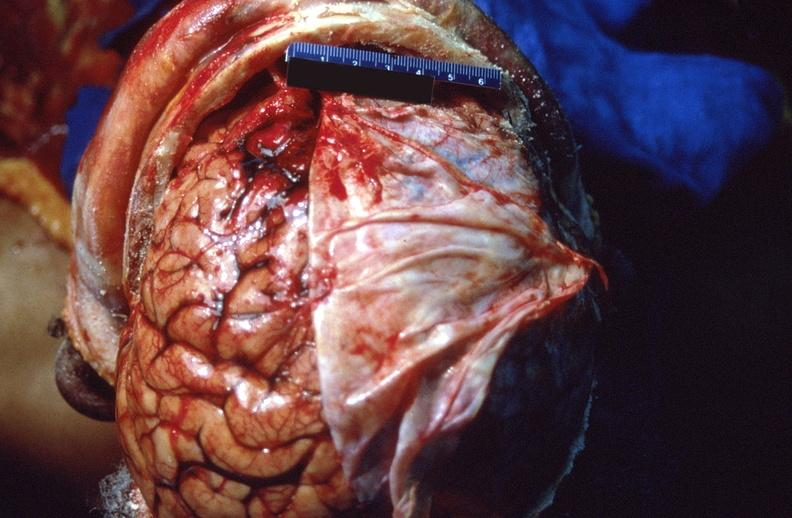s syndactyly present?
Answer the question using a single word or phrase. No 